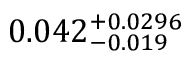<formula> <loc_0><loc_0><loc_500><loc_500>0 . 0 4 2 _ { - 0 . 0 1 9 } ^ { + 0 . 0 2 9 6 }</formula> 